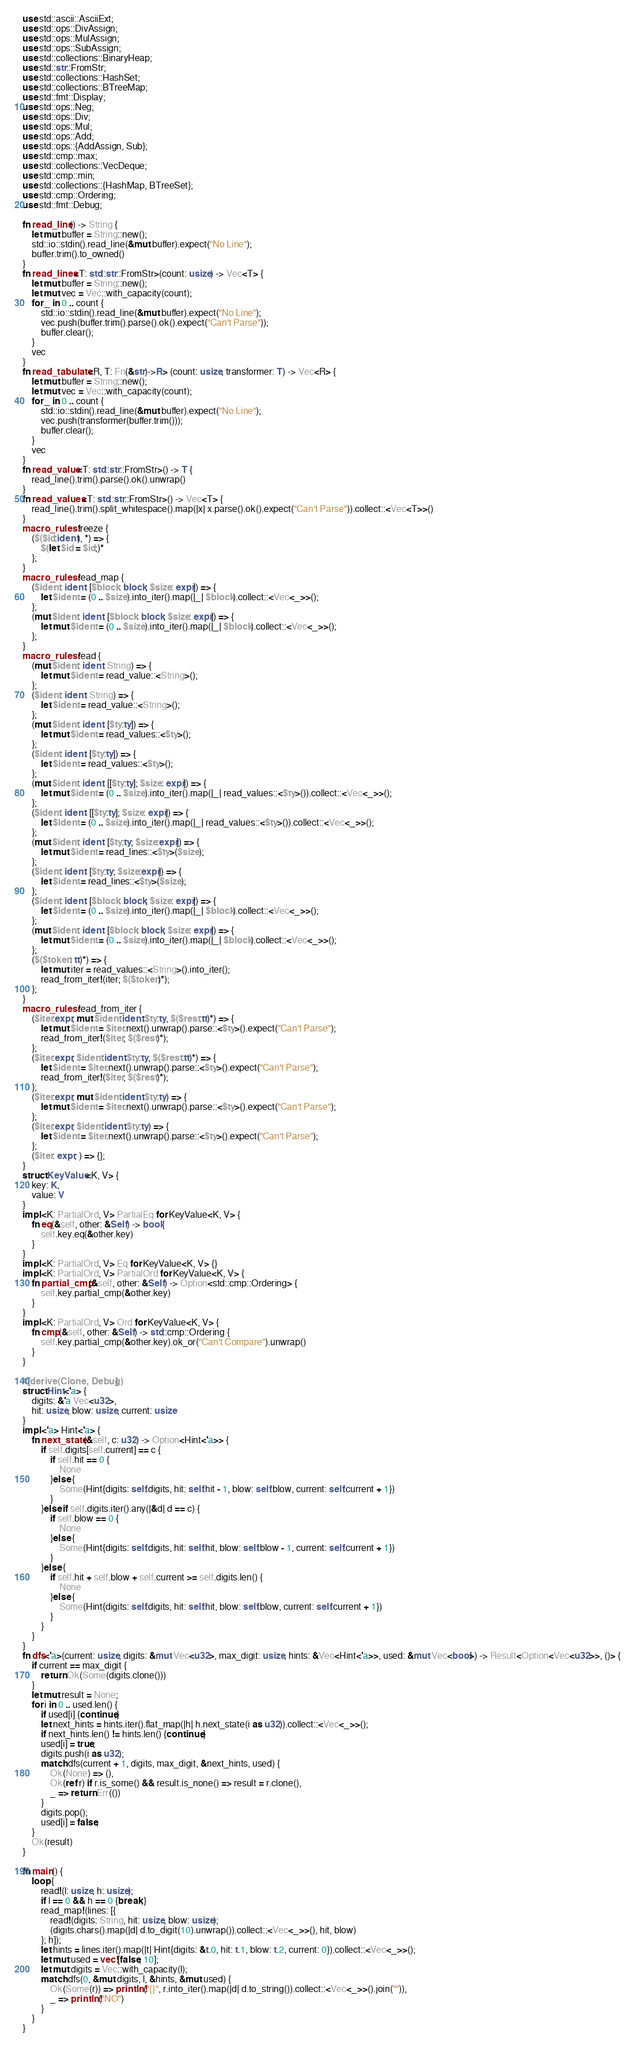Convert code to text. <code><loc_0><loc_0><loc_500><loc_500><_Rust_>use std::ascii::AsciiExt;
use std::ops::DivAssign;
use std::ops::MulAssign;
use std::ops::SubAssign;
use std::collections::BinaryHeap;
use std::str::FromStr;
use std::collections::HashSet;
use std::collections::BTreeMap;
use std::fmt::Display;
use std::ops::Neg;
use std::ops::Div;
use std::ops::Mul;
use std::ops::Add;
use std::ops::{AddAssign, Sub};
use std::cmp::max;
use std::collections::VecDeque;
use std::cmp::min;
use std::collections::{HashMap, BTreeSet};
use std::cmp::Ordering;
use std::fmt::Debug;

fn read_line() -> String {
    let mut buffer = String::new();
    std::io::stdin().read_line(&mut buffer).expect("No Line");
    buffer.trim().to_owned()
}
fn read_lines<T: std::str::FromStr>(count: usize) -> Vec<T> {
    let mut buffer = String::new();
    let mut vec = Vec::with_capacity(count);
    for _ in 0 .. count {
        std::io::stdin().read_line(&mut buffer).expect("No Line");
        vec.push(buffer.trim().parse().ok().expect("Can't Parse"));
        buffer.clear();
    }
    vec
}
fn read_tabulate<R, T: Fn(&str)->R> (count: usize, transformer: T) -> Vec<R> {
    let mut buffer = String::new();
    let mut vec = Vec::with_capacity(count);
    for _ in 0 .. count {
        std::io::stdin().read_line(&mut buffer).expect("No Line");
        vec.push(transformer(buffer.trim()));
        buffer.clear();
    }
    vec
}
fn read_value<T: std::str::FromStr>() -> T {
    read_line().trim().parse().ok().unwrap()
}
fn read_values<T: std::str::FromStr>() -> Vec<T> {
    read_line().trim().split_whitespace().map(|x| x.parse().ok().expect("Can't Parse")).collect::<Vec<T>>()
}
macro_rules! freeze {
    ($($id:ident), *) => {
        $(let $id = $id;)*
    };
}
macro_rules! read_map {
    ($ident: ident: [$block: block; $size: expr]) => {
        let $ident = (0 .. $size).into_iter().map(|_| $block).collect::<Vec<_>>();
    };
    (mut $ident: ident: [$block: block; $size: expr]) => {
        let mut $ident = (0 .. $size).into_iter().map(|_| $block).collect::<Vec<_>>();
    };
}
macro_rules! read {
    (mut $ident: ident: String) => {
        let mut $ident = read_value::<String>();
    };
    ($ident: ident: String) => {
        let $ident = read_value::<String>();
    };
    (mut $ident: ident: [$ty:ty]) => {
        let mut $ident = read_values::<$ty>();
    };
    ($ident: ident: [$ty:ty]) => {
        let $ident = read_values::<$ty>();
    };
    (mut $ident: ident: [[$ty:ty]; $size: expr]) => {
        let mut $ident = (0 .. $size).into_iter().map(|_| read_values::<$ty>()).collect::<Vec<_>>();
    };
    ($ident: ident: [[$ty:ty]; $size: expr]) => {
        let $ident = (0 .. $size).into_iter().map(|_| read_values::<$ty>()).collect::<Vec<_>>();
    };
    (mut $ident: ident: [$ty:ty; $size:expr]) => {
        let mut $ident = read_lines::<$ty>($size);
    };
    ($ident: ident: [$ty:ty; $size:expr]) => {
        let $ident = read_lines::<$ty>($size);
    };
    ($ident: ident: [$block: block; $size: expr]) => {
        let $ident = (0 .. $size).into_iter().map(|_| $block).collect::<Vec<_>>();
    };
    (mut $ident: ident: [$block: block; $size: expr]) => {
        let mut $ident = (0 .. $size).into_iter().map(|_| $block).collect::<Vec<_>>();
    };
    ($($token: tt)*) => {
        let mut iter = read_values::<String>().into_iter();
        read_from_iter!(iter; $($token)*);
    };
}
macro_rules! read_from_iter {
    ($iter:expr; mut $ident:ident:$ty:ty, $($rest:tt)*) => {
        let mut $ident = $iter.next().unwrap().parse::<$ty>().expect("Can't Parse");
        read_from_iter!($iter; $($rest)*);
    };
    ($iter:expr; $ident:ident:$ty:ty, $($rest:tt)*) => {
        let $ident = $iter.next().unwrap().parse::<$ty>().expect("Can't Parse");
        read_from_iter!($iter; $($rest)*);
    };
    ($iter:expr; mut $ident:ident:$ty:ty) => {
        let mut $ident = $iter.next().unwrap().parse::<$ty>().expect("Can't Parse");
    };
    ($iter:expr; $ident:ident:$ty:ty) => {
        let $ident = $iter.next().unwrap().parse::<$ty>().expect("Can't Parse");
    };
    ($iter: expr; ) => {};
}
struct KeyValue<K, V> {
    key: K,
    value: V
}
impl <K: PartialOrd, V> PartialEq for KeyValue<K, V> {
    fn eq(&self, other: &Self) -> bool {
        self.key.eq(&other.key)
    }
}
impl <K: PartialOrd, V> Eq for KeyValue<K, V> {}
impl <K: PartialOrd, V> PartialOrd for KeyValue<K, V> {
    fn partial_cmp(&self, other: &Self) -> Option<std::cmp::Ordering> {
        self.key.partial_cmp(&other.key)
    }
}
impl <K: PartialOrd, V> Ord for KeyValue<K, V> {
    fn cmp(&self, other: &Self) -> std::cmp::Ordering {
        self.key.partial_cmp(&other.key).ok_or("Can't Compare").unwrap()
    }
}

#[derive(Clone, Debug)]
struct Hint<'a> {
    digits: &'a Vec<u32>,
    hit: usize, blow: usize, current: usize
}
impl <'a> Hint<'a> {
    fn next_state(&self, c: u32) -> Option<Hint<'a>> {
        if self.digits[self.current] == c {
            if self.hit == 0 {
                None
            }else {
                Some(Hint{digits: self.digits, hit: self.hit - 1, blow: self.blow, current: self.current + 1})
            }
        }else if self.digits.iter().any(|&d| d == c) {
            if self.blow == 0 {
                None
            }else {
                Some(Hint{digits: self.digits, hit: self.hit, blow: self.blow - 1, current: self.current + 1})
            }
        }else {
            if self.hit + self.blow + self.current >= self.digits.len() {
                None
            }else {
                Some(Hint{digits: self.digits, hit: self.hit, blow: self.blow, current: self.current + 1})
            }
        }
    }
}
fn dfs<'a>(current: usize, digits: &mut Vec<u32>, max_digit: usize, hints: &Vec<Hint<'a>>, used: &mut Vec<bool>) -> Result<Option<Vec<u32>>, ()> {
    if current == max_digit {
        return Ok(Some(digits.clone()))
    }
    let mut result = None;
    for i in 0 .. used.len() {
        if used[i] {continue;}
        let next_hints = hints.iter().flat_map(|h| h.next_state(i as u32)).collect::<Vec<_>>();
        if next_hints.len() != hints.len() {continue;}
        used[i] = true;
        digits.push(i as u32);
        match dfs(current + 1, digits, max_digit, &next_hints, used) {
            Ok(None) => (),
            Ok(ref r) if r.is_some() && result.is_none() => result = r.clone(),
            _ => return Err(())
        }
        digits.pop();
        used[i] = false;
    }
    Ok(result)
} 

fn main() {
    loop {
        read!(l: usize, h: usize);
        if l == 0 && h == 0 {break;}
        read_map!(lines: [{
            read!(digits: String, hit: usize, blow: usize);
            (digits.chars().map(|d| d.to_digit(10).unwrap()).collect::<Vec<_>>(), hit, blow)
        }; h]);
        let hints = lines.iter().map(|t| Hint{digits: &t.0, hit: t.1, blow: t.2, current: 0}).collect::<Vec<_>>();
        let mut used = vec![false; 10];
        let mut digits = Vec::with_capacity(l);
        match dfs(0, &mut digits, l, &hints, &mut used) {
            Ok(Some(r)) => println!("{}", r.into_iter().map(|d| d.to_string()).collect::<Vec<_>>().join("")),
            _ => println!("NO")
        }
    }
}
</code> 